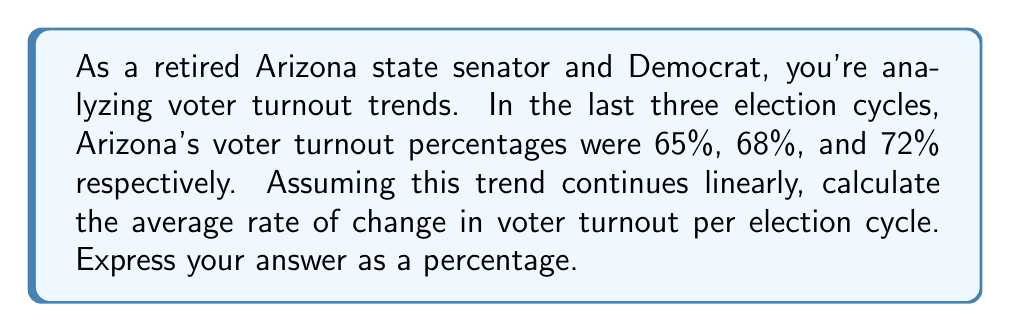Teach me how to tackle this problem. To solve this problem, we need to calculate the average rate of change in voter turnout over the given election cycles. Let's approach this step-by-step:

1) First, let's define our variables:
   $x$ = election cycle number (1, 2, 3)
   $y$ = voter turnout percentage

2) We have the following data points:
   $(1, 65\%)$, $(2, 68\%)$, $(3, 72\%)$

3) The rate of change formula is:

   $$\text{Rate of change} = \frac{\text{Change in y}}{\text{Change in x}}$$

4) To find the average rate of change, we'll use the first and last data points:

   $$\text{Average rate of change} = \frac{y_3 - y_1}{x_3 - x_1} = \frac{72\% - 65\%}{3 - 1} = \frac{7\%}{2}$$

5) Simplify the fraction:

   $$\frac{7\%}{2} = 3.5\%$$

Therefore, the average rate of change in voter turnout is 3.5% per election cycle.
Answer: 3.5% per election cycle 